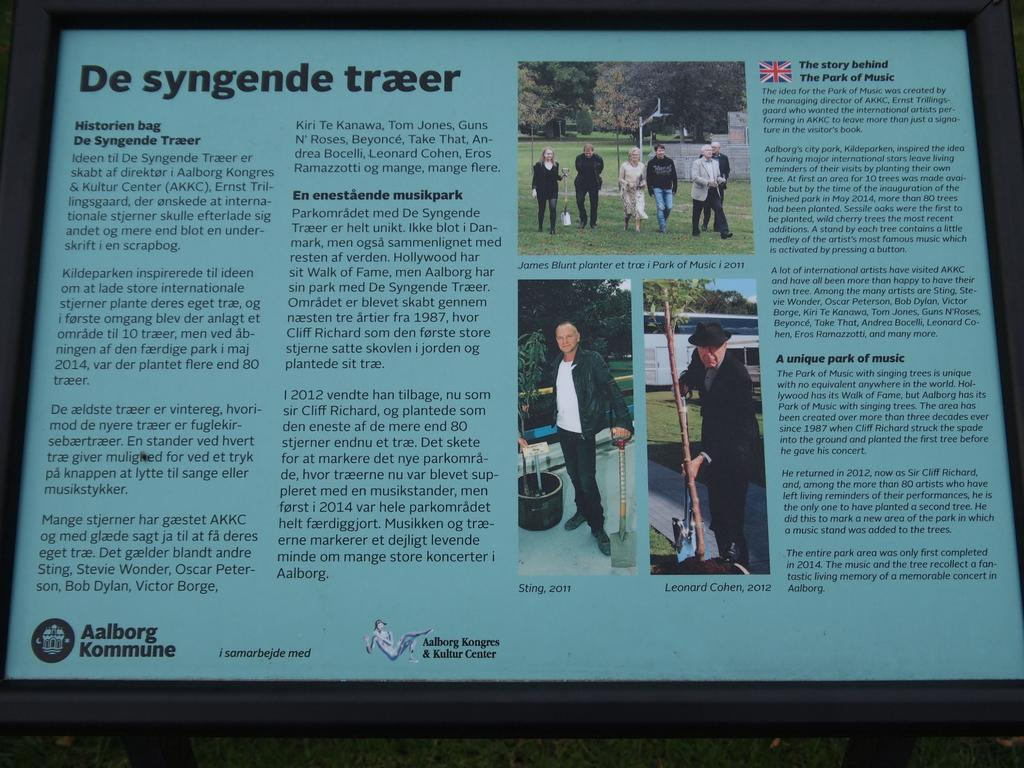<image>
Provide a brief description of the given image. the display at the aalborg Kongres and Kultur center is full of information 